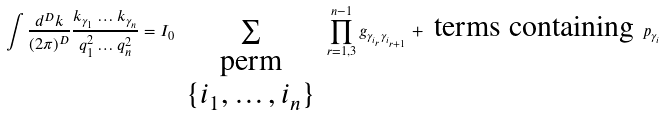Convert formula to latex. <formula><loc_0><loc_0><loc_500><loc_500>\int \frac { d ^ { D } k } { ( 2 \pi ) ^ { D } } \frac { k _ { \gamma _ { 1 } } \dots k _ { \gamma _ { n } } } { q _ { 1 } ^ { 2 } \dots q _ { n } ^ { 2 } } = I _ { 0 } \sum _ { \begin{array} { c } \text {perm} \\ \{ i _ { 1 } , \dots , i _ { n } \} \end{array} } \prod _ { r = 1 , 3 } ^ { n - 1 } g _ { \gamma _ { i _ { r } } \gamma _ { i _ { r + 1 } } } + \text {  terms containing } p _ { \gamma _ { i } }</formula> 